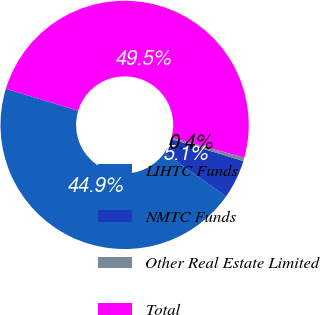Convert chart to OTSL. <chart><loc_0><loc_0><loc_500><loc_500><pie_chart><fcel>LIHTC Funds<fcel>NMTC Funds<fcel>Other Real Estate Limited<fcel>Total<nl><fcel>44.93%<fcel>5.07%<fcel>0.45%<fcel>49.55%<nl></chart> 